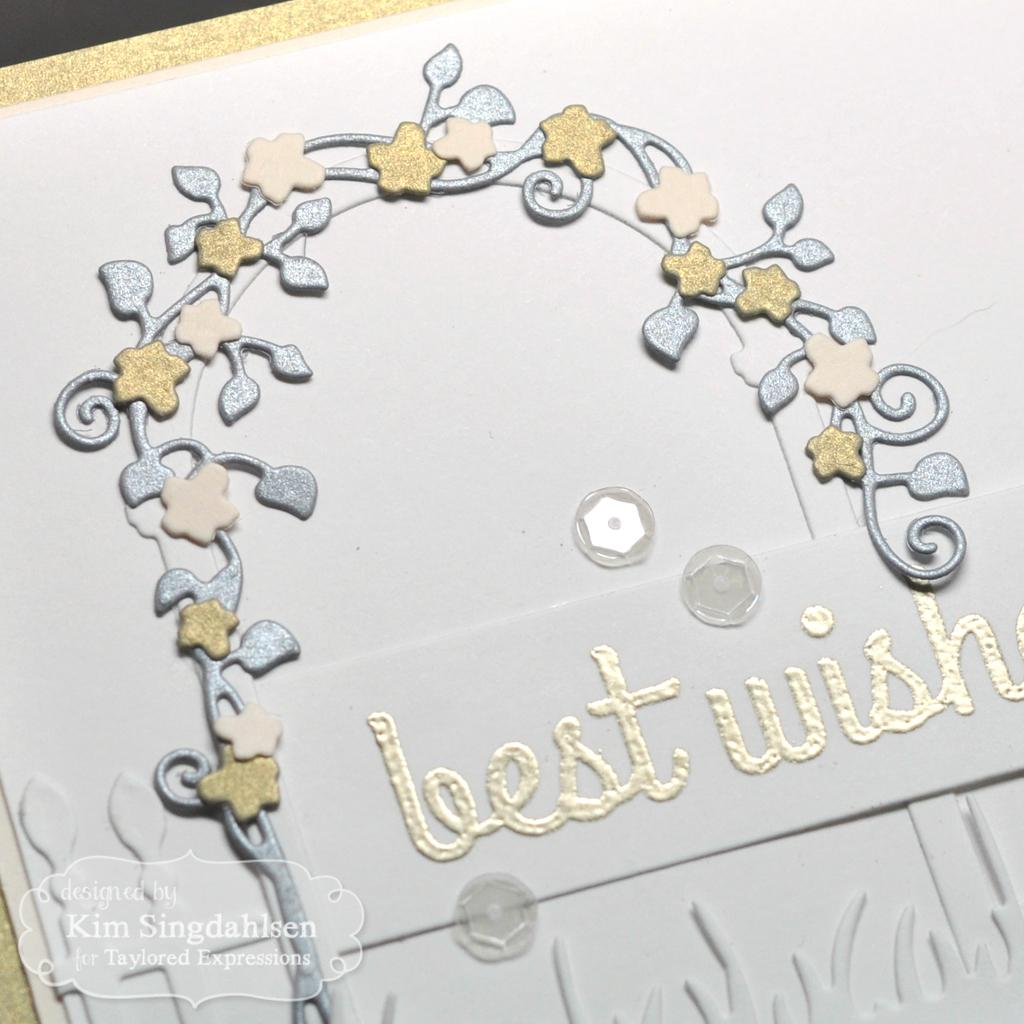What is the main subject of the image? There is a designed card in the image. What other elements can be seen in the image? Buttons are visible in the image. Where is the watermark located in the image? The watermark is at the bottom left side of the image. Can you see a collar on the designed card in the image? No, there is no collar present on the designed card in the image. Is there a house visible in the image? No, there is no house visible in the image; it only features a designed card, buttons, and a watermark. 